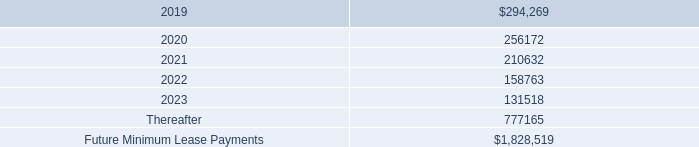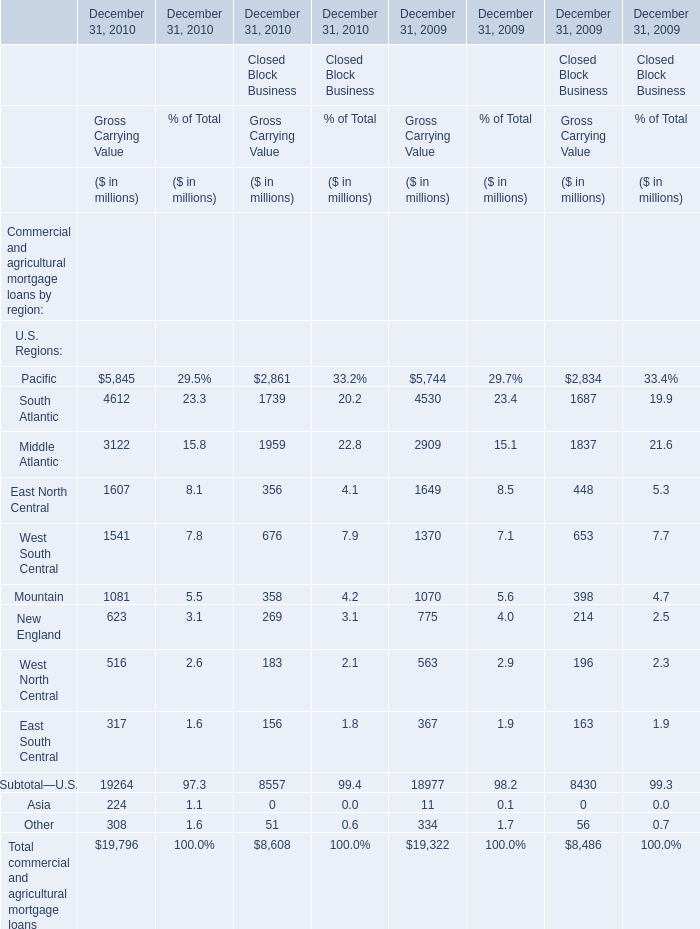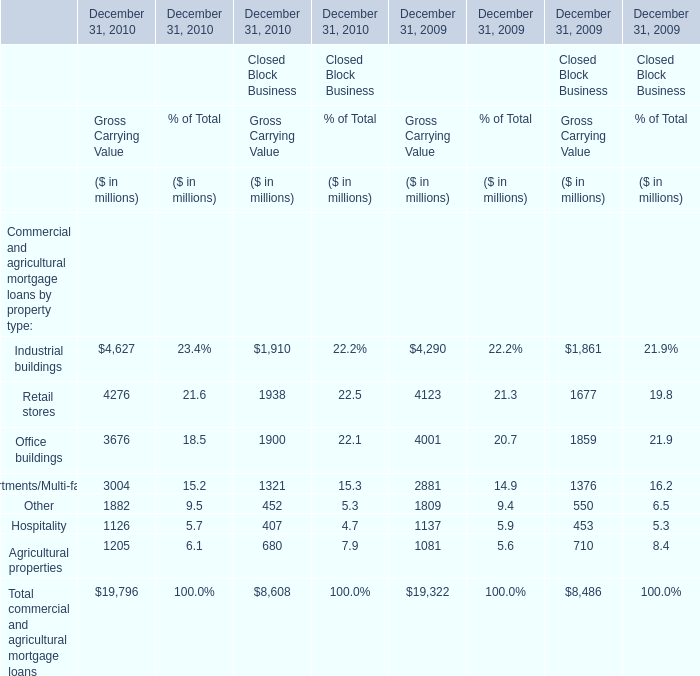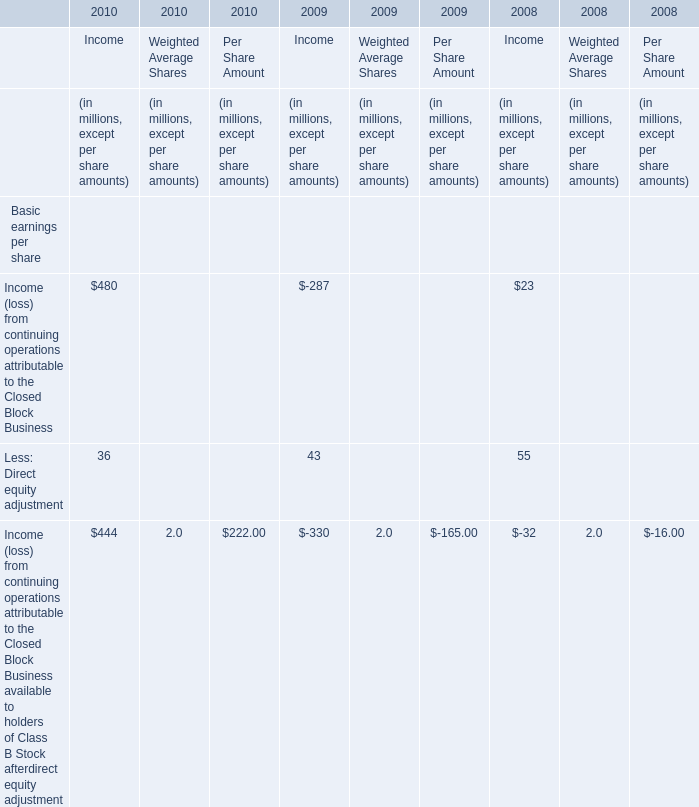When does Pacific in Gross Carrying Value reach the largest value? 
Answer: December 31, 2010. 